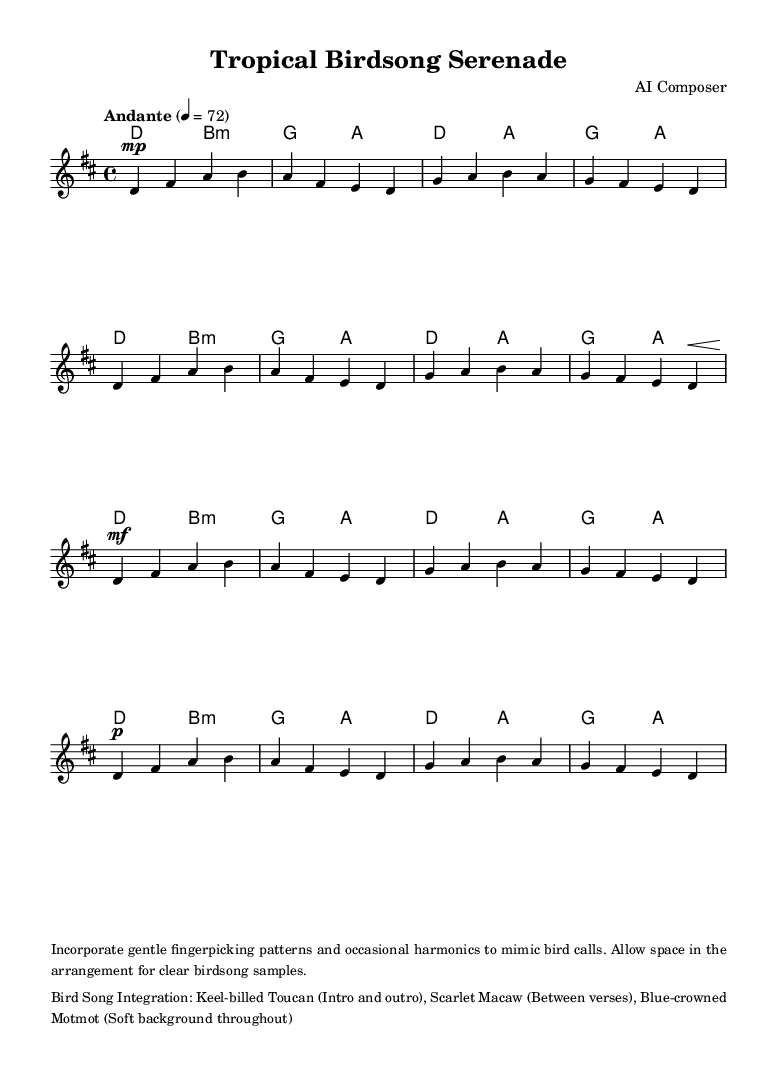What is the key signature of this music? The key signature is indicated at the beginning, showing two sharps, which corresponds to D major.
Answer: D major What is the time signature of this music? The time signature is indicated at the beginning with the fraction 4/4, meaning there are four beats in each measure.
Answer: 4/4 What is the tempo marking for this piece? The tempo marking is provided in words and numbers, stating "Andante" with a beats-per-minute value of 72.
Answer: Andante, 72 How many measures are there in the chorus section? The chorus is indicated in the music and consists of four measures, counted from d4 to g fis e d.
Answer: 4 Which bird call integrates with the intro and outro? The music lists the specific integration of bird calls, noting that the Keel-billed Toucan plays a role in both the intro and outro segments.
Answer: Keel-billed Toucan How many chords are in the entire piece of music? The chord progression in the score consists of repeating patterns through each section. Counting all recurring instances indicates there are 12 unique chords used throughout.
Answer: 12 